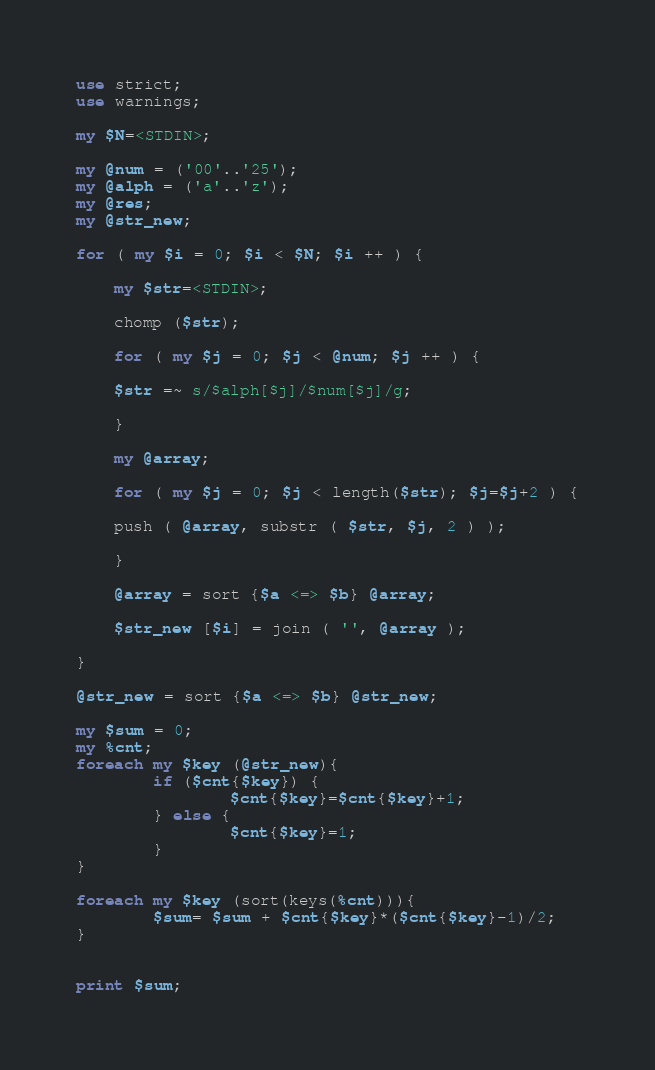<code> <loc_0><loc_0><loc_500><loc_500><_Perl_>use strict;
use warnings;
    
my $N=<STDIN>;

my @num = ('00'..'25');
my @alph = ('a'..'z');
my @res;
my @str_new;

for ( my $i = 0; $i < $N; $i ++ ) {

    my $str=<STDIN>;
    
    chomp ($str);

    for ( my $j = 0; $j < @num; $j ++ ) {
	
	$str =~ s/$alph[$j]/$num[$j]/g;
	
    }
    
    my @array;
    
    for ( my $j = 0; $j < length($str); $j=$j+2 ) {
	
	push ( @array, substr ( $str, $j, 2 ) );
	
    }

    @array = sort {$a <=> $b} @array;

    $str_new [$i] = join ( '', @array );

}

@str_new = sort {$a <=> $b} @str_new;

my $sum = 0;
my %cnt;
foreach my $key (@str_new){
        if ($cnt{$key}) {
                $cnt{$key}=$cnt{$key}+1;
        } else {
                $cnt{$key}=1;
        }
}

foreach my $key (sort(keys(%cnt))){
        $sum= $sum + $cnt{$key}*($cnt{$key}-1)/2;
}


print $sum;
</code> 